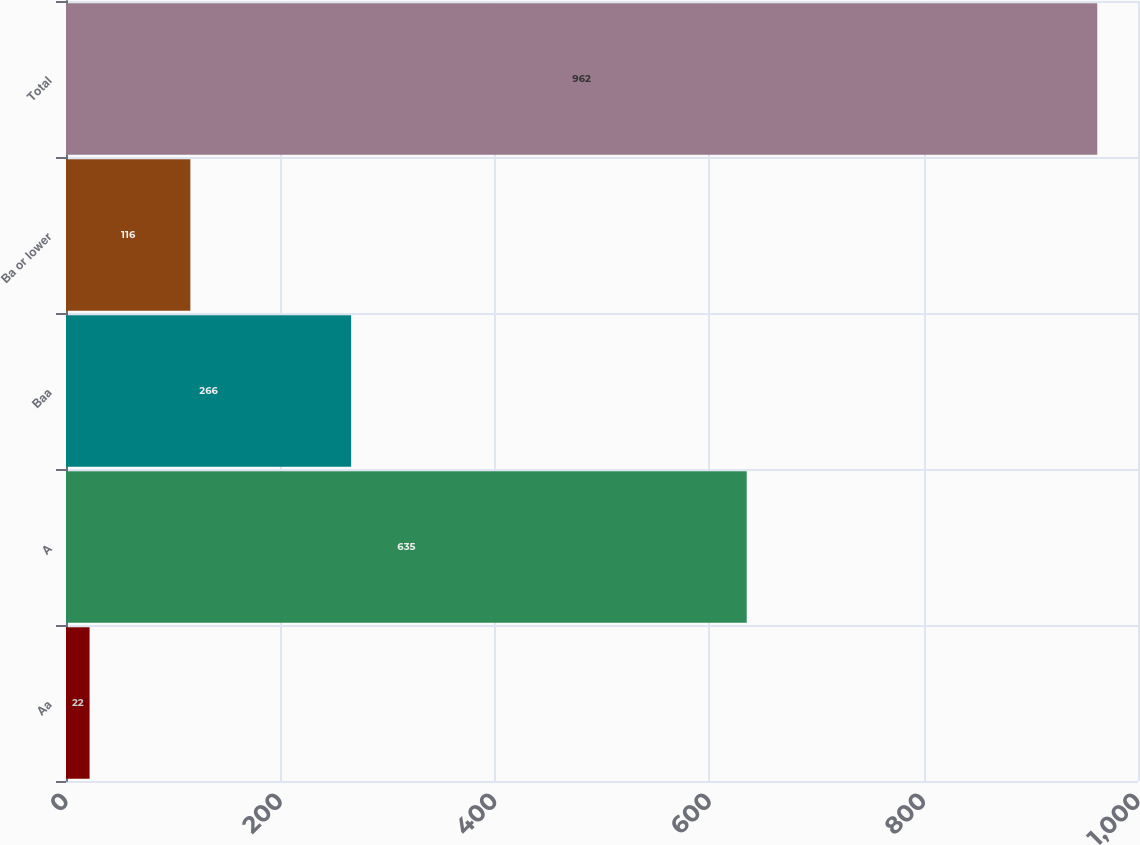<chart> <loc_0><loc_0><loc_500><loc_500><bar_chart><fcel>Aa<fcel>A<fcel>Baa<fcel>Ba or lower<fcel>Total<nl><fcel>22<fcel>635<fcel>266<fcel>116<fcel>962<nl></chart> 